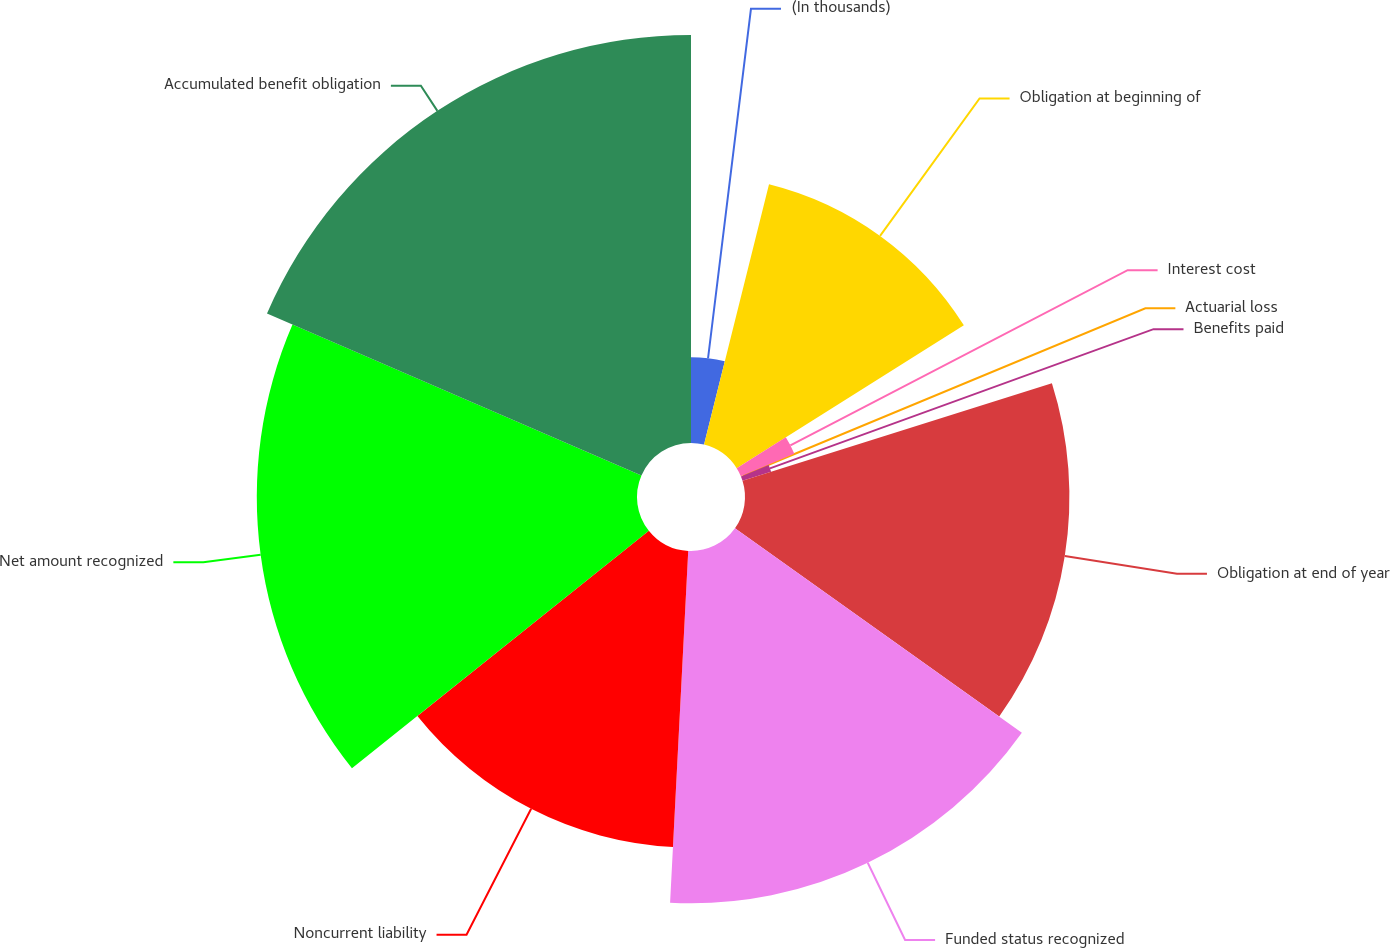Convert chart to OTSL. <chart><loc_0><loc_0><loc_500><loc_500><pie_chart><fcel>(In thousands)<fcel>Obligation at beginning of<fcel>Interest cost<fcel>Actuarial loss<fcel>Benefits paid<fcel>Obligation at end of year<fcel>Funded status recognized<fcel>Noncurrent liability<fcel>Net amount recognized<fcel>Accumulated benefit obligation<nl><fcel>3.89%<fcel>12.17%<fcel>2.63%<fcel>0.09%<fcel>1.36%<fcel>14.71%<fcel>15.97%<fcel>13.44%<fcel>17.24%<fcel>18.5%<nl></chart> 